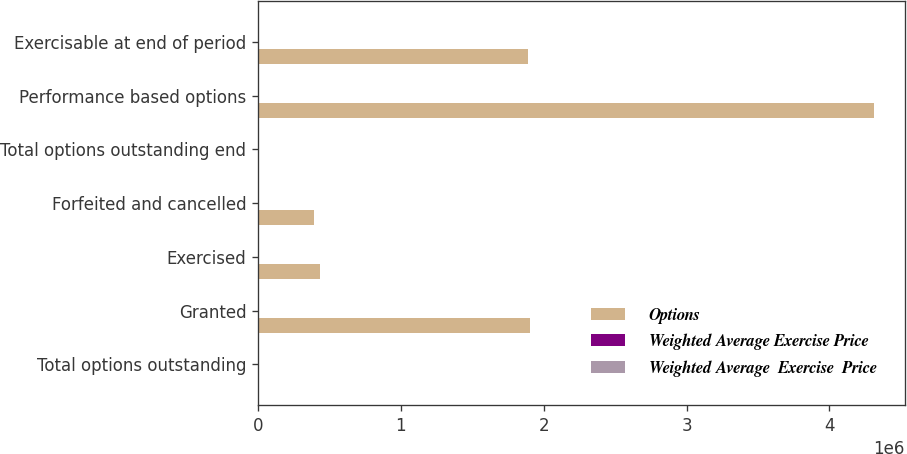Convert chart to OTSL. <chart><loc_0><loc_0><loc_500><loc_500><stacked_bar_chart><ecel><fcel>Total options outstanding<fcel>Granted<fcel>Exercised<fcel>Forfeited and cancelled<fcel>Total options outstanding end<fcel>Performance based options<fcel>Exercisable at end of period<nl><fcel>Options<fcel>31.39<fcel>1.901e+06<fcel>431092<fcel>392584<fcel>31.39<fcel>4.312e+06<fcel>1.89281e+06<nl><fcel>Weighted Average Exercise Price<fcel>31.13<fcel>54.41<fcel>23.36<fcel>50.03<fcel>36.21<fcel>31.39<fcel>29.97<nl><fcel>Weighted Average  Exercise  Price<fcel>24.51<fcel>69.11<fcel>16.15<fcel>21.78<fcel>31.13<fcel>28.03<fcel>26.82<nl></chart> 